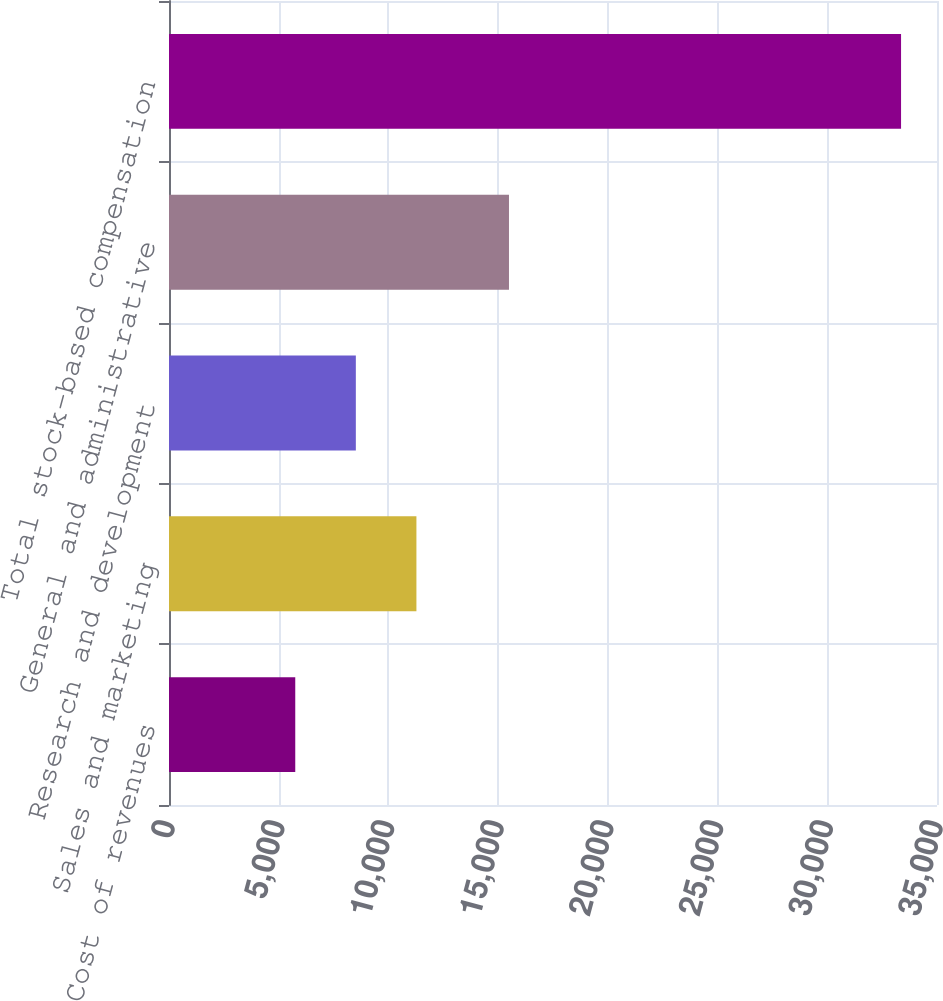<chart> <loc_0><loc_0><loc_500><loc_500><bar_chart><fcel>Cost of revenues<fcel>Sales and marketing<fcel>Research and development<fcel>General and administrative<fcel>Total stock-based compensation<nl><fcel>5754<fcel>11275.6<fcel>8514.8<fcel>15494<fcel>33362<nl></chart> 